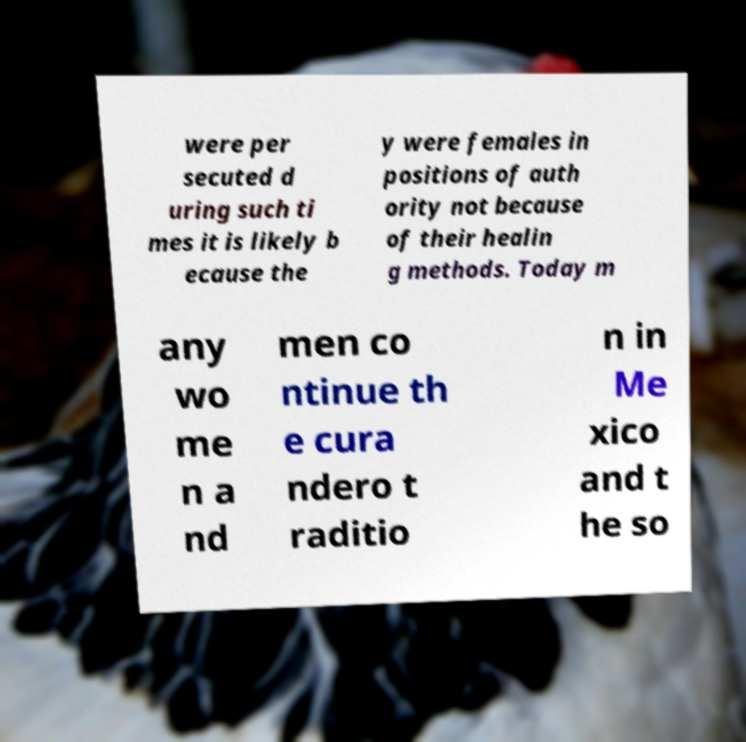For documentation purposes, I need the text within this image transcribed. Could you provide that? were per secuted d uring such ti mes it is likely b ecause the y were females in positions of auth ority not because of their healin g methods. Today m any wo me n a nd men co ntinue th e cura ndero t raditio n in Me xico and t he so 